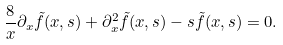Convert formula to latex. <formula><loc_0><loc_0><loc_500><loc_500>\frac { 8 } { x } \partial _ { x } \tilde { f } ( x , s ) + \partial ^ { 2 } _ { x } \tilde { f } ( x , s ) - s \tilde { f } ( x , s ) = 0 .</formula> 